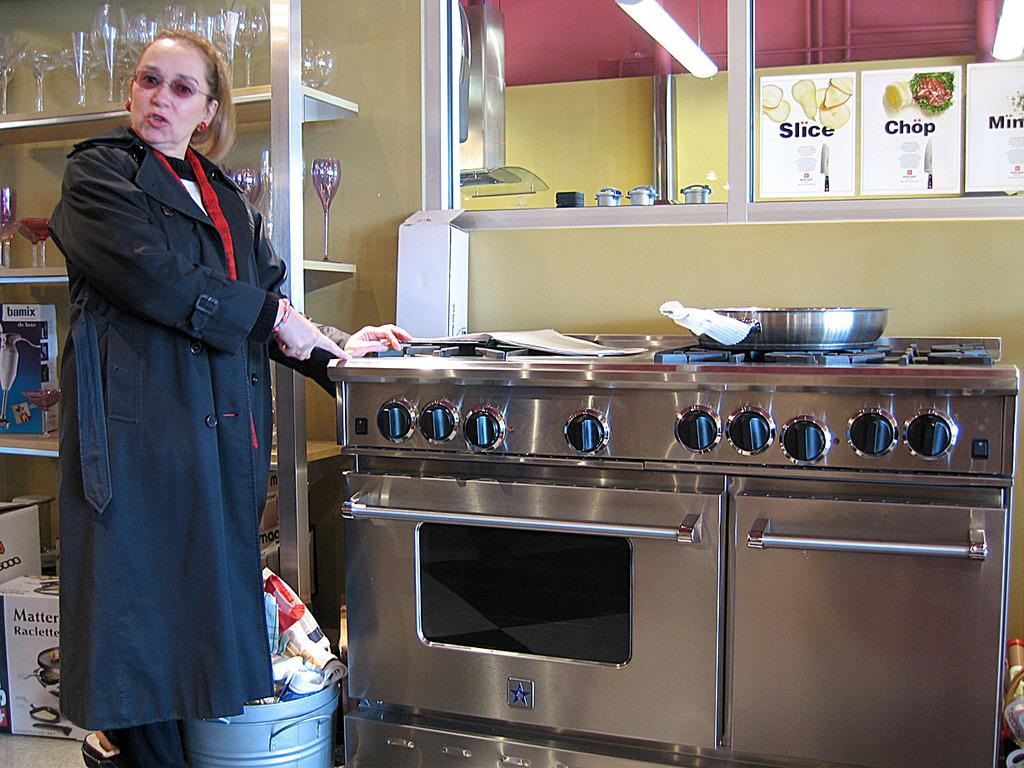<image>
Create a compact narrative representing the image presented. A woman is standing near a stove that has signs above it saying Slice, Chop, and Mince. 